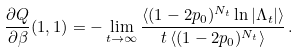Convert formula to latex. <formula><loc_0><loc_0><loc_500><loc_500>\frac { \partial Q } { \partial \beta } ( 1 , 1 ) = - \lim _ { t \to \infty } \frac { \langle ( 1 - 2 p _ { 0 } ) ^ { N _ { t } } \ln | \Lambda _ { t } | \rangle } { t \, \langle ( 1 - 2 p _ { 0 } ) ^ { N _ { t } } \rangle } \, .</formula> 